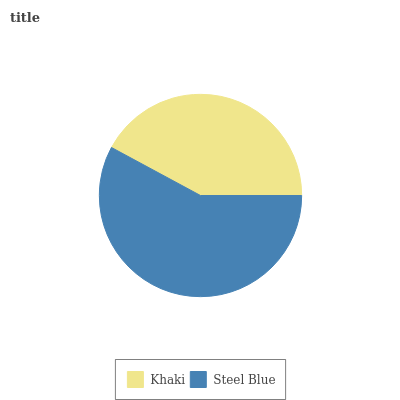Is Khaki the minimum?
Answer yes or no. Yes. Is Steel Blue the maximum?
Answer yes or no. Yes. Is Steel Blue the minimum?
Answer yes or no. No. Is Steel Blue greater than Khaki?
Answer yes or no. Yes. Is Khaki less than Steel Blue?
Answer yes or no. Yes. Is Khaki greater than Steel Blue?
Answer yes or no. No. Is Steel Blue less than Khaki?
Answer yes or no. No. Is Steel Blue the high median?
Answer yes or no. Yes. Is Khaki the low median?
Answer yes or no. Yes. Is Khaki the high median?
Answer yes or no. No. Is Steel Blue the low median?
Answer yes or no. No. 